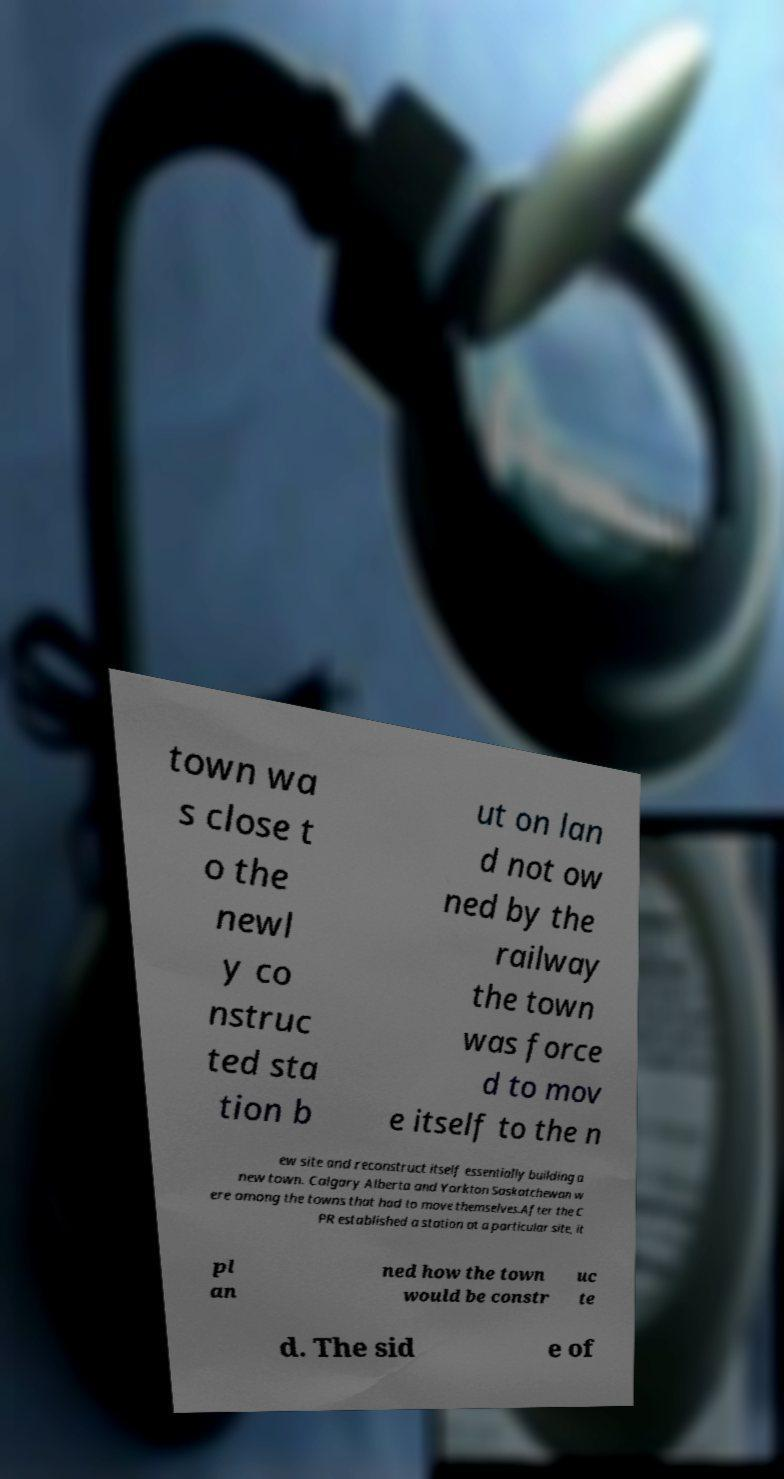I need the written content from this picture converted into text. Can you do that? town wa s close t o the newl y co nstruc ted sta tion b ut on lan d not ow ned by the railway the town was force d to mov e itself to the n ew site and reconstruct itself essentially building a new town. Calgary Alberta and Yorkton Saskatchewan w ere among the towns that had to move themselves.After the C PR established a station at a particular site, it pl an ned how the town would be constr uc te d. The sid e of 